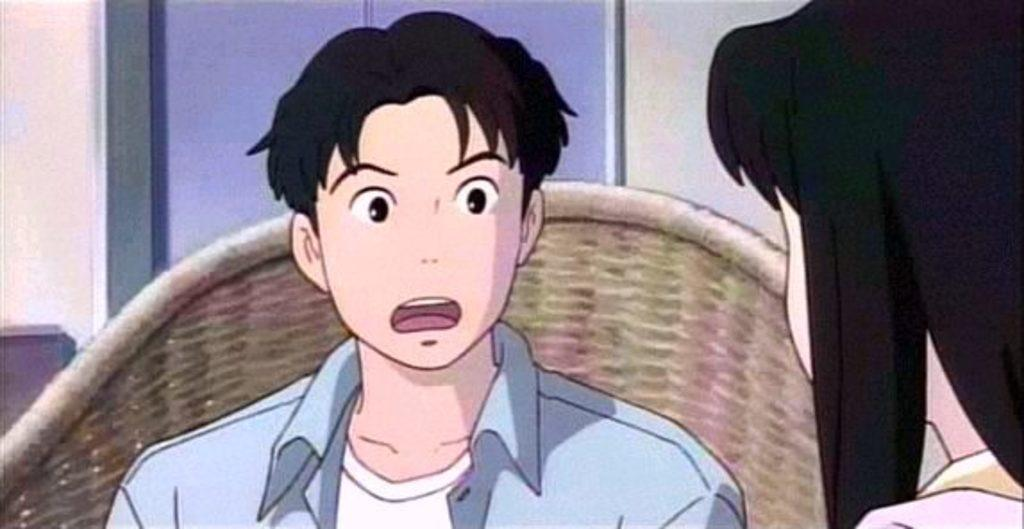What type of image is being described? The image is animated. How many people are present in the image? There are two persons in the image. What piece of furniture can be seen in the image? There is a chair in the image. Is there any source of natural light in the image? Yes, there is a window in the image. What type of wood can be seen in the image? There is no wood present in the image. How many crackers are being eaten by the persons in the image? There is no mention of crackers in the image; it only features two persons and a chair. 